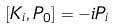Convert formula to latex. <formula><loc_0><loc_0><loc_500><loc_500>[ K _ { i } , P _ { 0 } ] = - i P _ { i }</formula> 